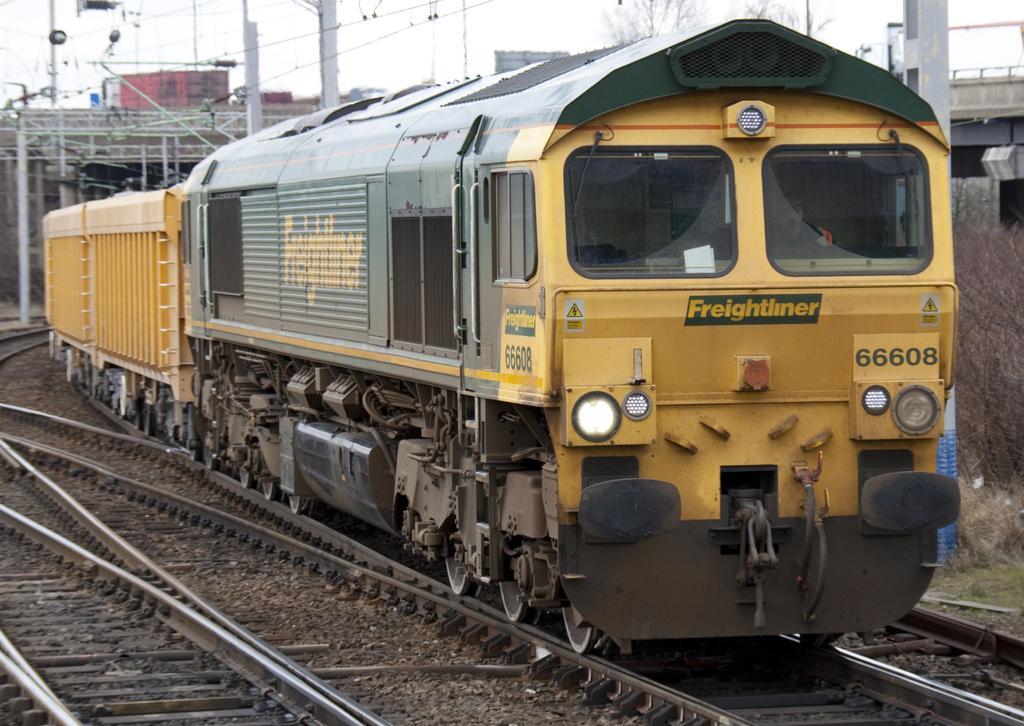Could you give a brief overview of what you see in this image? This image is taken outdoors. At the bottom of the image there are a few railway tracks on the ground. In the middle of the image a train is moving on the track. In the background there are a few poles with wires. There is a tree and there are a few walls. There are a few iron bars. 